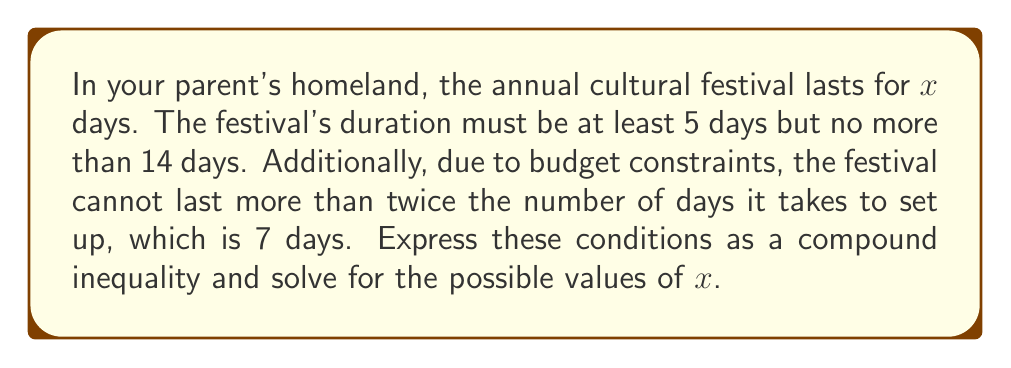Could you help me with this problem? Let's break this down step by step:

1) The festival lasts at least 5 days:
   $x \geq 5$

2) The festival lasts no more than 14 days:
   $x \leq 14$

3) The festival cannot last more than twice the setup time (7 days):
   $x \leq 2(7) = 14$

4) Combining these conditions, we get the compound inequality:
   $5 \leq x \leq 14$

5) To solve this, we need to find all integer values of $x$ that satisfy this inequality.

6) The possible integer values for $x$ are:
   $5, 6, 7, 8, 9, 10, 11, 12, 13, 14$

Therefore, the festival can last for any integer number of days from 5 to 14, inclusive.
Answer: $x \in \{5, 6, 7, 8, 9, 10, 11, 12, 13, 14\}$ 